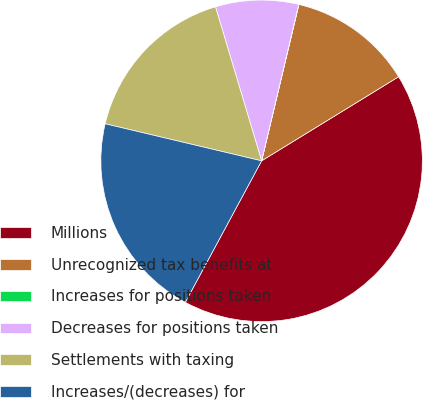Convert chart. <chart><loc_0><loc_0><loc_500><loc_500><pie_chart><fcel>Millions<fcel>Unrecognized tax benefits at<fcel>Increases for positions taken<fcel>Decreases for positions taken<fcel>Settlements with taxing<fcel>Increases/(decreases) for<nl><fcel>41.64%<fcel>12.51%<fcel>0.02%<fcel>8.34%<fcel>16.67%<fcel>20.83%<nl></chart> 